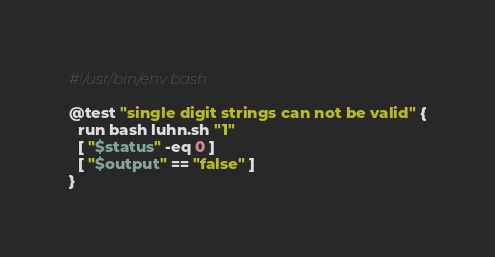Convert code to text. <code><loc_0><loc_0><loc_500><loc_500><_Bash_>#!/usr/bin/env bash

@test "single digit strings can not be valid" {
  run bash luhn.sh "1"
  [ "$status" -eq 0 ]
  [ "$output" == "false" ]
}
</code> 